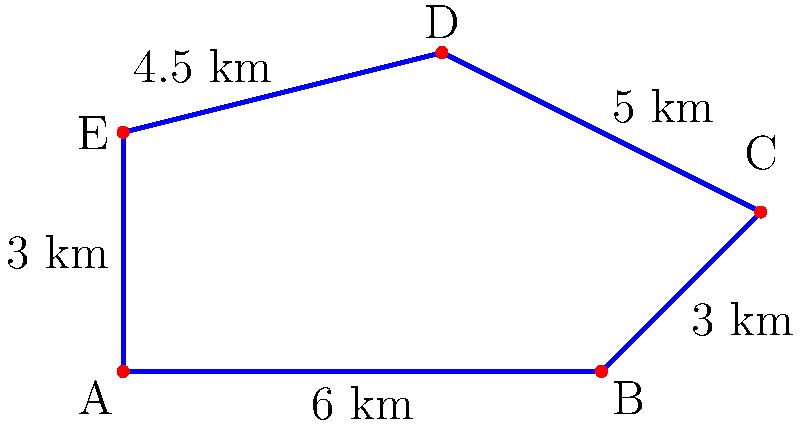A new geothermal energy field is proposed with a polygonal boundary as shown in the diagram. The sides of the polygon represent the perimeter fence needed to secure the area. If the cost of fencing is $75,000 per kilometer, what would be the total cost to fence the entire perimeter of the geothermal field? To solve this problem, we need to follow these steps:

1. Calculate the perimeter of the polygon:
   - Sum up the lengths of all sides
   - Perimeter = 6 km + 3 km + 5 km + 4.5 km + 3 km = 21.5 km

2. Calculate the cost of fencing:
   - Multiply the perimeter by the cost per kilometer
   - Total cost = 21.5 km × $75,000/km = $1,612,500

Therefore, the total cost to fence the entire perimeter of the geothermal field would be $1,612,500.
Answer: $1,612,500 